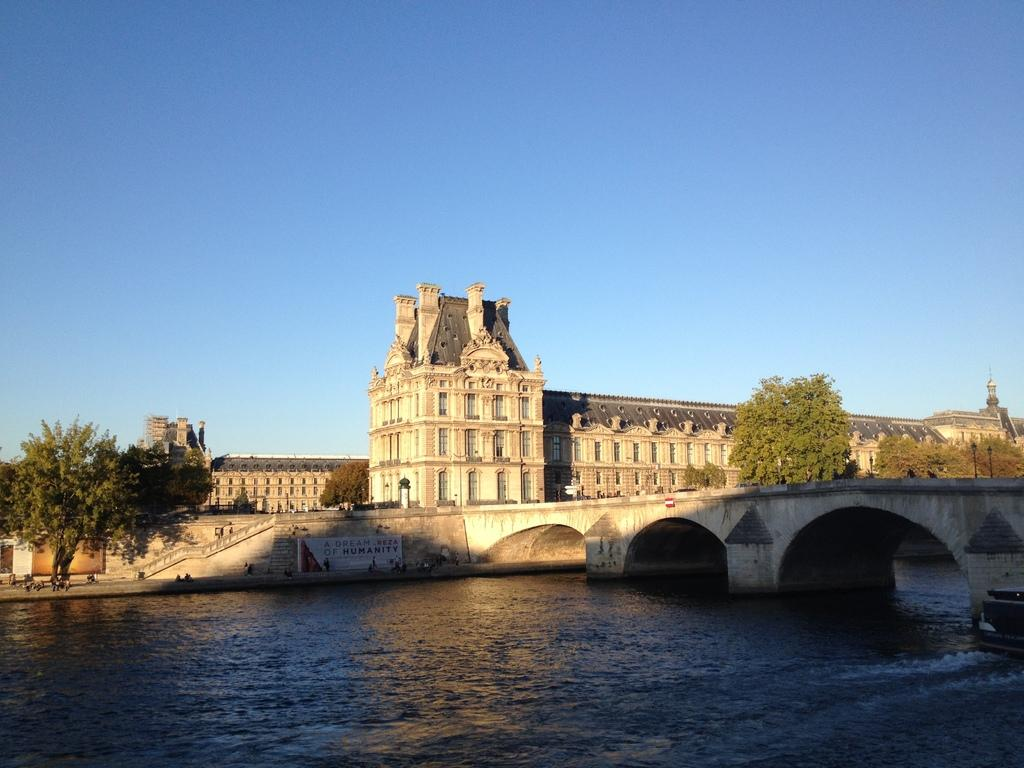What type of structures can be seen in the image? There are buildings in the image. What are the people in the image doing? There are persons on the floor in the image. What are some other objects visible in the image? Street poles, street lights, trees, and a staircase are present in the image. What natural feature can be seen in the image? There is a bridge over a river in the image. What part of the environment is visible in the image? The sky is visible in the image. What type of wine is being served at the discovery event in the image? There is no discovery event or wine present in the image. What stage of development is the project in, as seen in the image? There is no project or development stage mentioned or depicted in the image. 